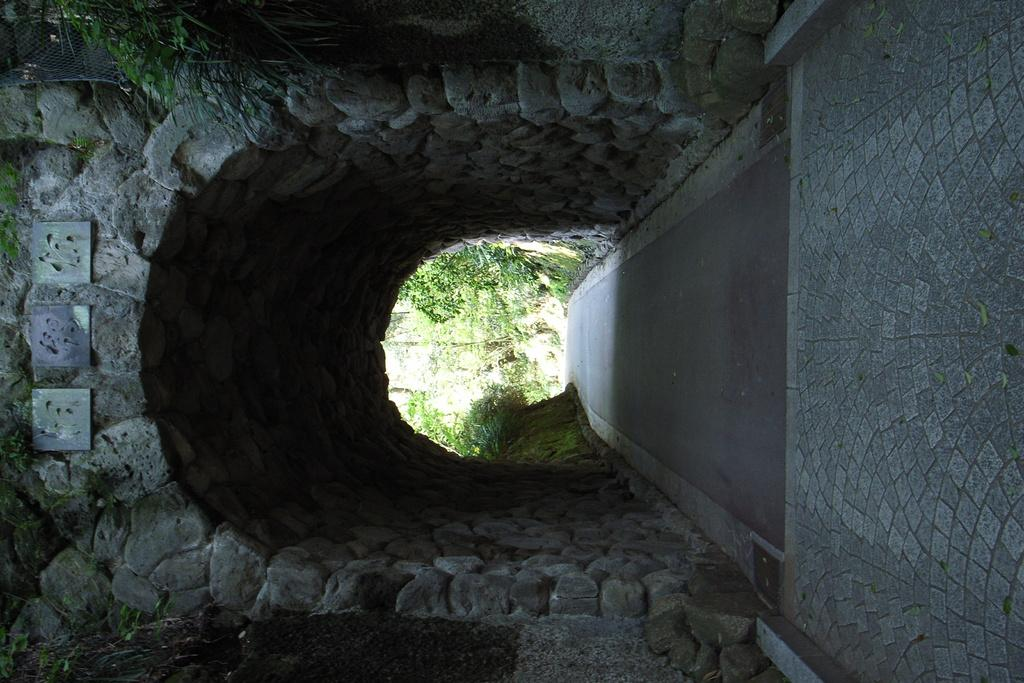What is the main feature of the image? There is a tunnel in the image. What can be seen at the bottom of the tunnel? There is a road at the bottom of the tunnel. What surrounds the road through the tunnel? Trees are visible on either side of the road through the tunnel. What type of flowers can be seen growing on the frog in the image? There is no frog present in the image, and therefore no flowers growing on it. 